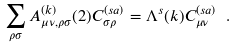Convert formula to latex. <formula><loc_0><loc_0><loc_500><loc_500>\sum _ { \rho \sigma } A ^ { ( k ) } _ { \mu \nu , \rho \sigma } ( 2 ) C ^ { ( s a ) } _ { \sigma \rho } = \Lambda ^ { s } ( k ) C ^ { ( s a ) } _ { \mu \nu } \ .</formula> 